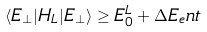Convert formula to latex. <formula><loc_0><loc_0><loc_500><loc_500>\langle E _ { \perp } | H _ { L } | E _ { \perp } \rangle \geq E ^ { L } _ { 0 } + \Delta E _ { e } n t</formula> 